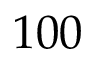<formula> <loc_0><loc_0><loc_500><loc_500>1 0 0</formula> 